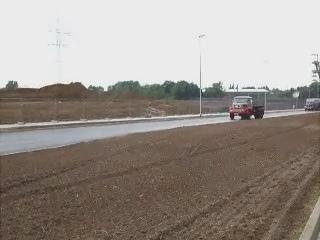Is this a grassy area?
Be succinct. No. Is the street busy with cars?
Give a very brief answer. No. Is the road smooth enough for skateboarding?
Concise answer only. No. What type of vehicle is approaching?
Give a very brief answer. Truck. Is there a speed limit for cars on this road?
Concise answer only. Yes. Is this in countryside?
Be succinct. Yes. 